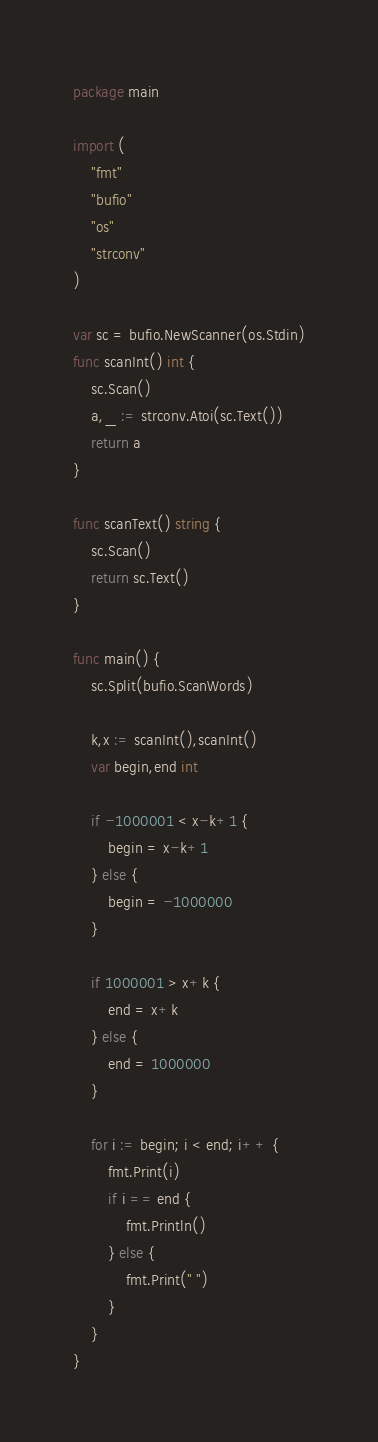Convert code to text. <code><loc_0><loc_0><loc_500><loc_500><_Go_>package main

import (
	"fmt"
	"bufio"
	"os"
	"strconv"
)

var sc = bufio.NewScanner(os.Stdin)
func scanInt() int {
	sc.Scan()
	a,_ := strconv.Atoi(sc.Text())
	return a
}

func scanText() string {
	sc.Scan()
	return sc.Text()
}

func main() {
	sc.Split(bufio.ScanWords)
	
	k,x := scanInt(),scanInt()
	var begin,end int

	if -1000001 < x-k+1 {
		begin = x-k+1
	} else {
		begin = -1000000
	}

	if 1000001 > x+k {
		end = x+k
	} else {
		end = 1000000
	}

	for i := begin; i < end; i++ {
		fmt.Print(i)
		if i == end {
			fmt.Println()
		} else {
			fmt.Print(" ")
		}
	}
}
</code> 